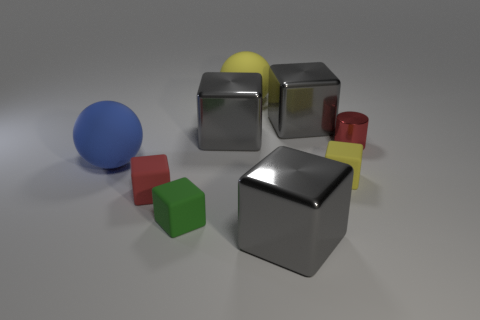Are there any other things that are the same shape as the red metallic object? Yes, the red metallic object is a cylinder, and there are two other objects with a cylindrical shape in the image, albeit in different sizes and colors; one is smaller and yellow, and the other is taller and red. 